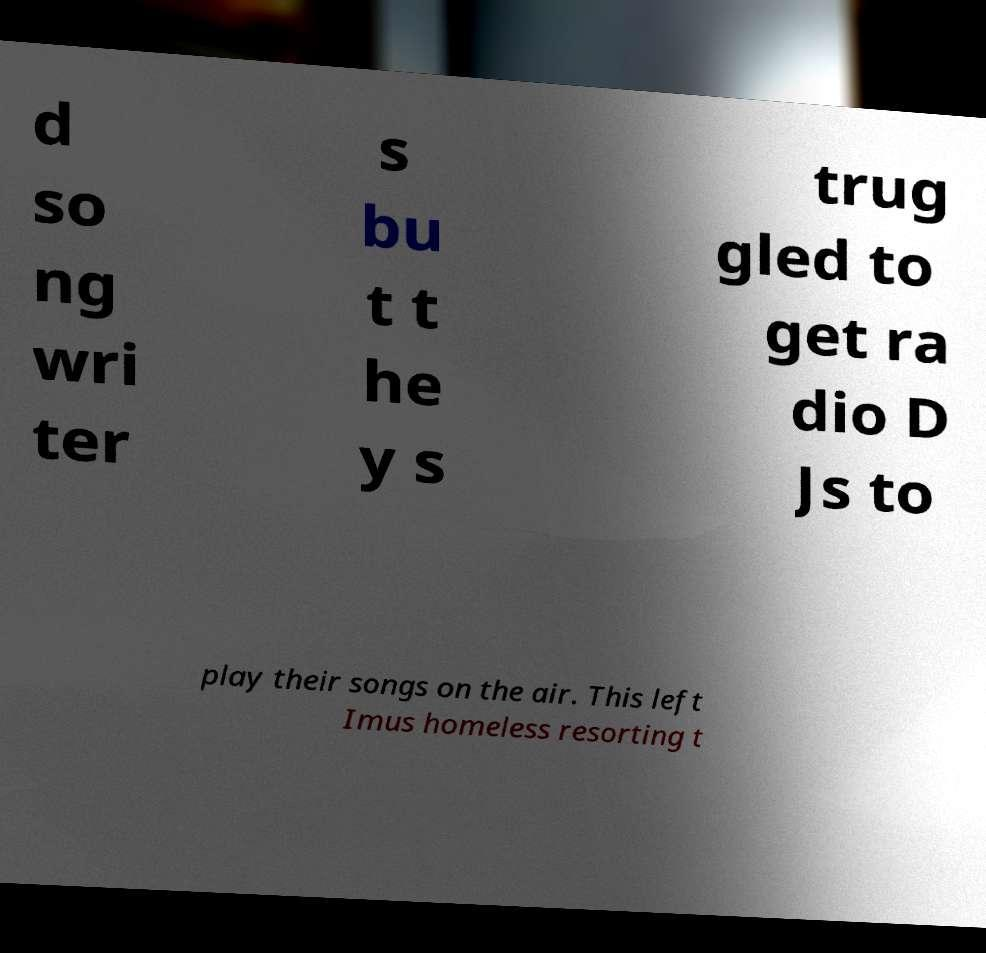Can you accurately transcribe the text from the provided image for me? d so ng wri ter s bu t t he y s trug gled to get ra dio D Js to play their songs on the air. This left Imus homeless resorting t 